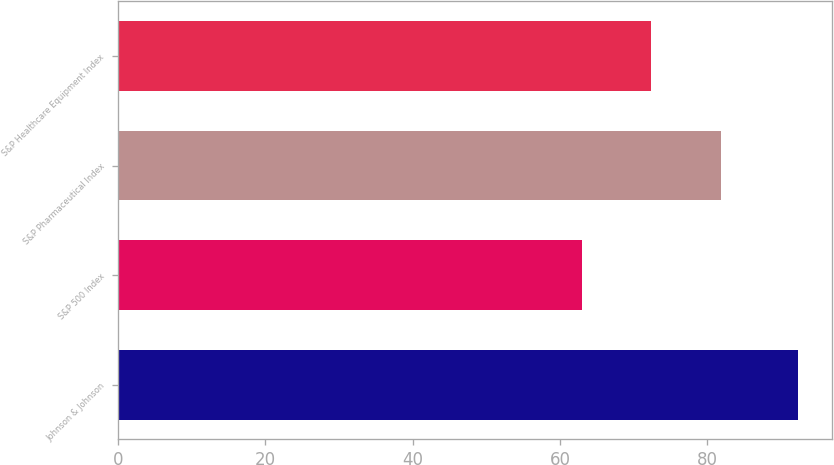Convert chart to OTSL. <chart><loc_0><loc_0><loc_500><loc_500><bar_chart><fcel>Johnson & Johnson<fcel>S&P 500 Index<fcel>S&P Pharmaceutical Index<fcel>S&P Healthcare Equipment Index<nl><fcel>92.23<fcel>63<fcel>81.8<fcel>72.36<nl></chart> 